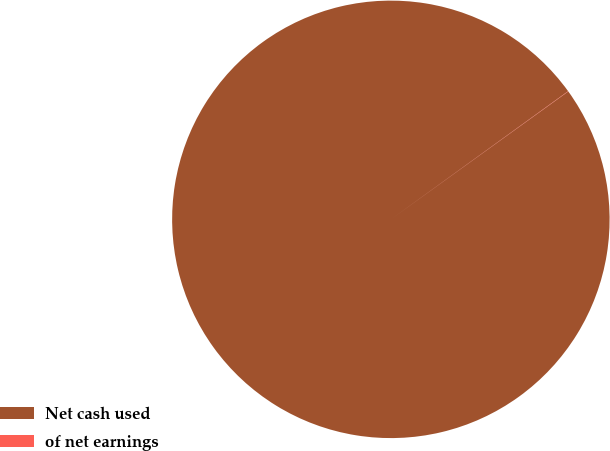<chart> <loc_0><loc_0><loc_500><loc_500><pie_chart><fcel>Net cash used<fcel>of net earnings<nl><fcel>99.98%<fcel>0.02%<nl></chart> 